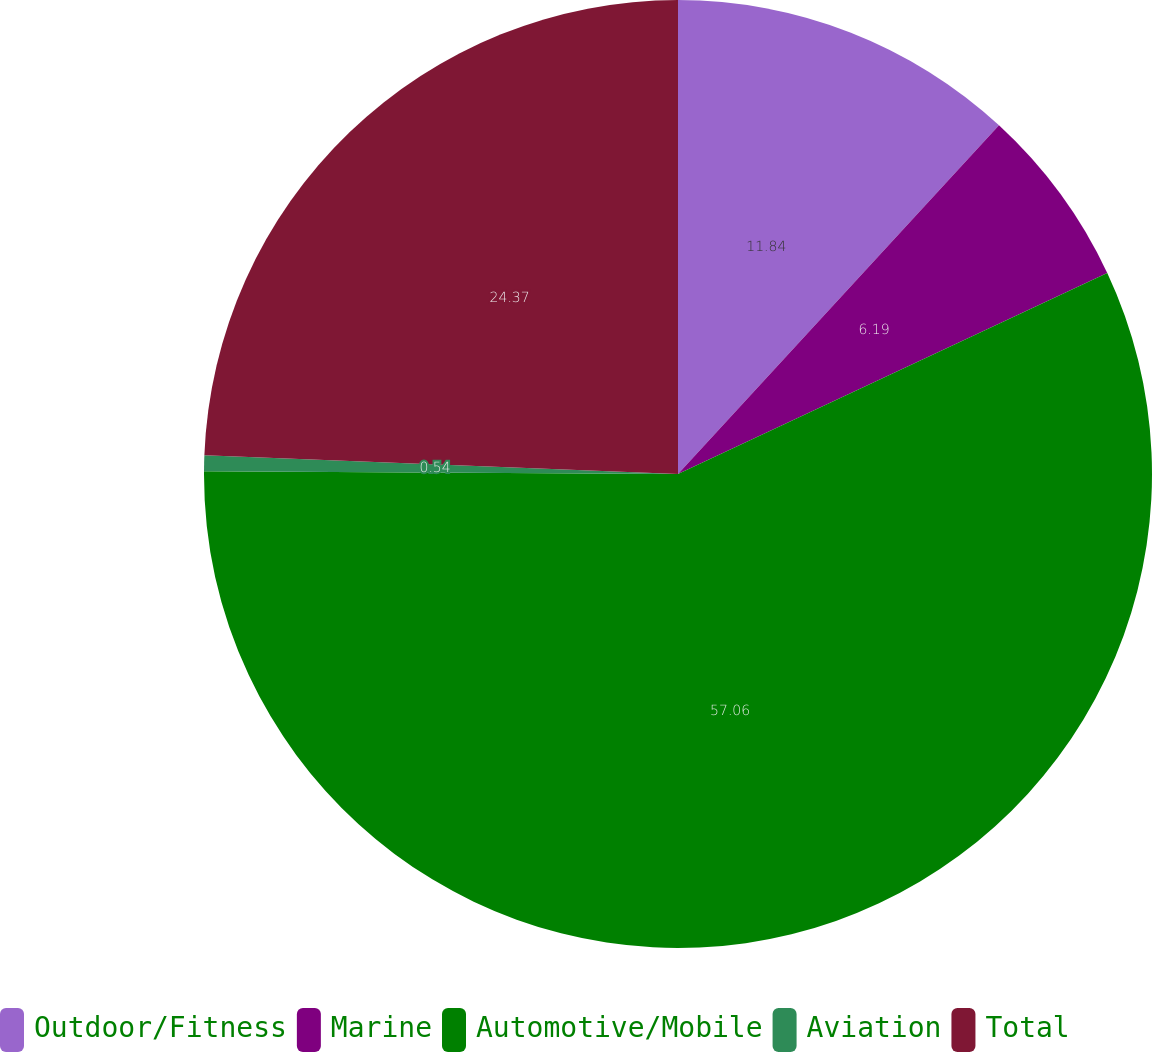Convert chart. <chart><loc_0><loc_0><loc_500><loc_500><pie_chart><fcel>Outdoor/Fitness<fcel>Marine<fcel>Automotive/Mobile<fcel>Aviation<fcel>Total<nl><fcel>11.84%<fcel>6.19%<fcel>57.06%<fcel>0.54%<fcel>24.37%<nl></chart> 